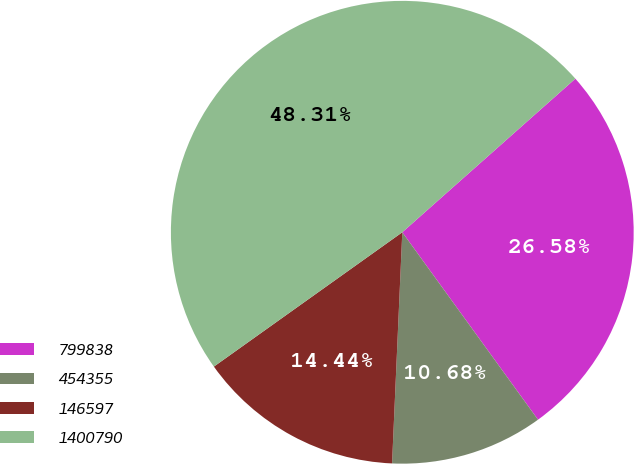Convert chart to OTSL. <chart><loc_0><loc_0><loc_500><loc_500><pie_chart><fcel>799838<fcel>454355<fcel>146597<fcel>1400790<nl><fcel>26.58%<fcel>10.68%<fcel>14.44%<fcel>48.31%<nl></chart> 